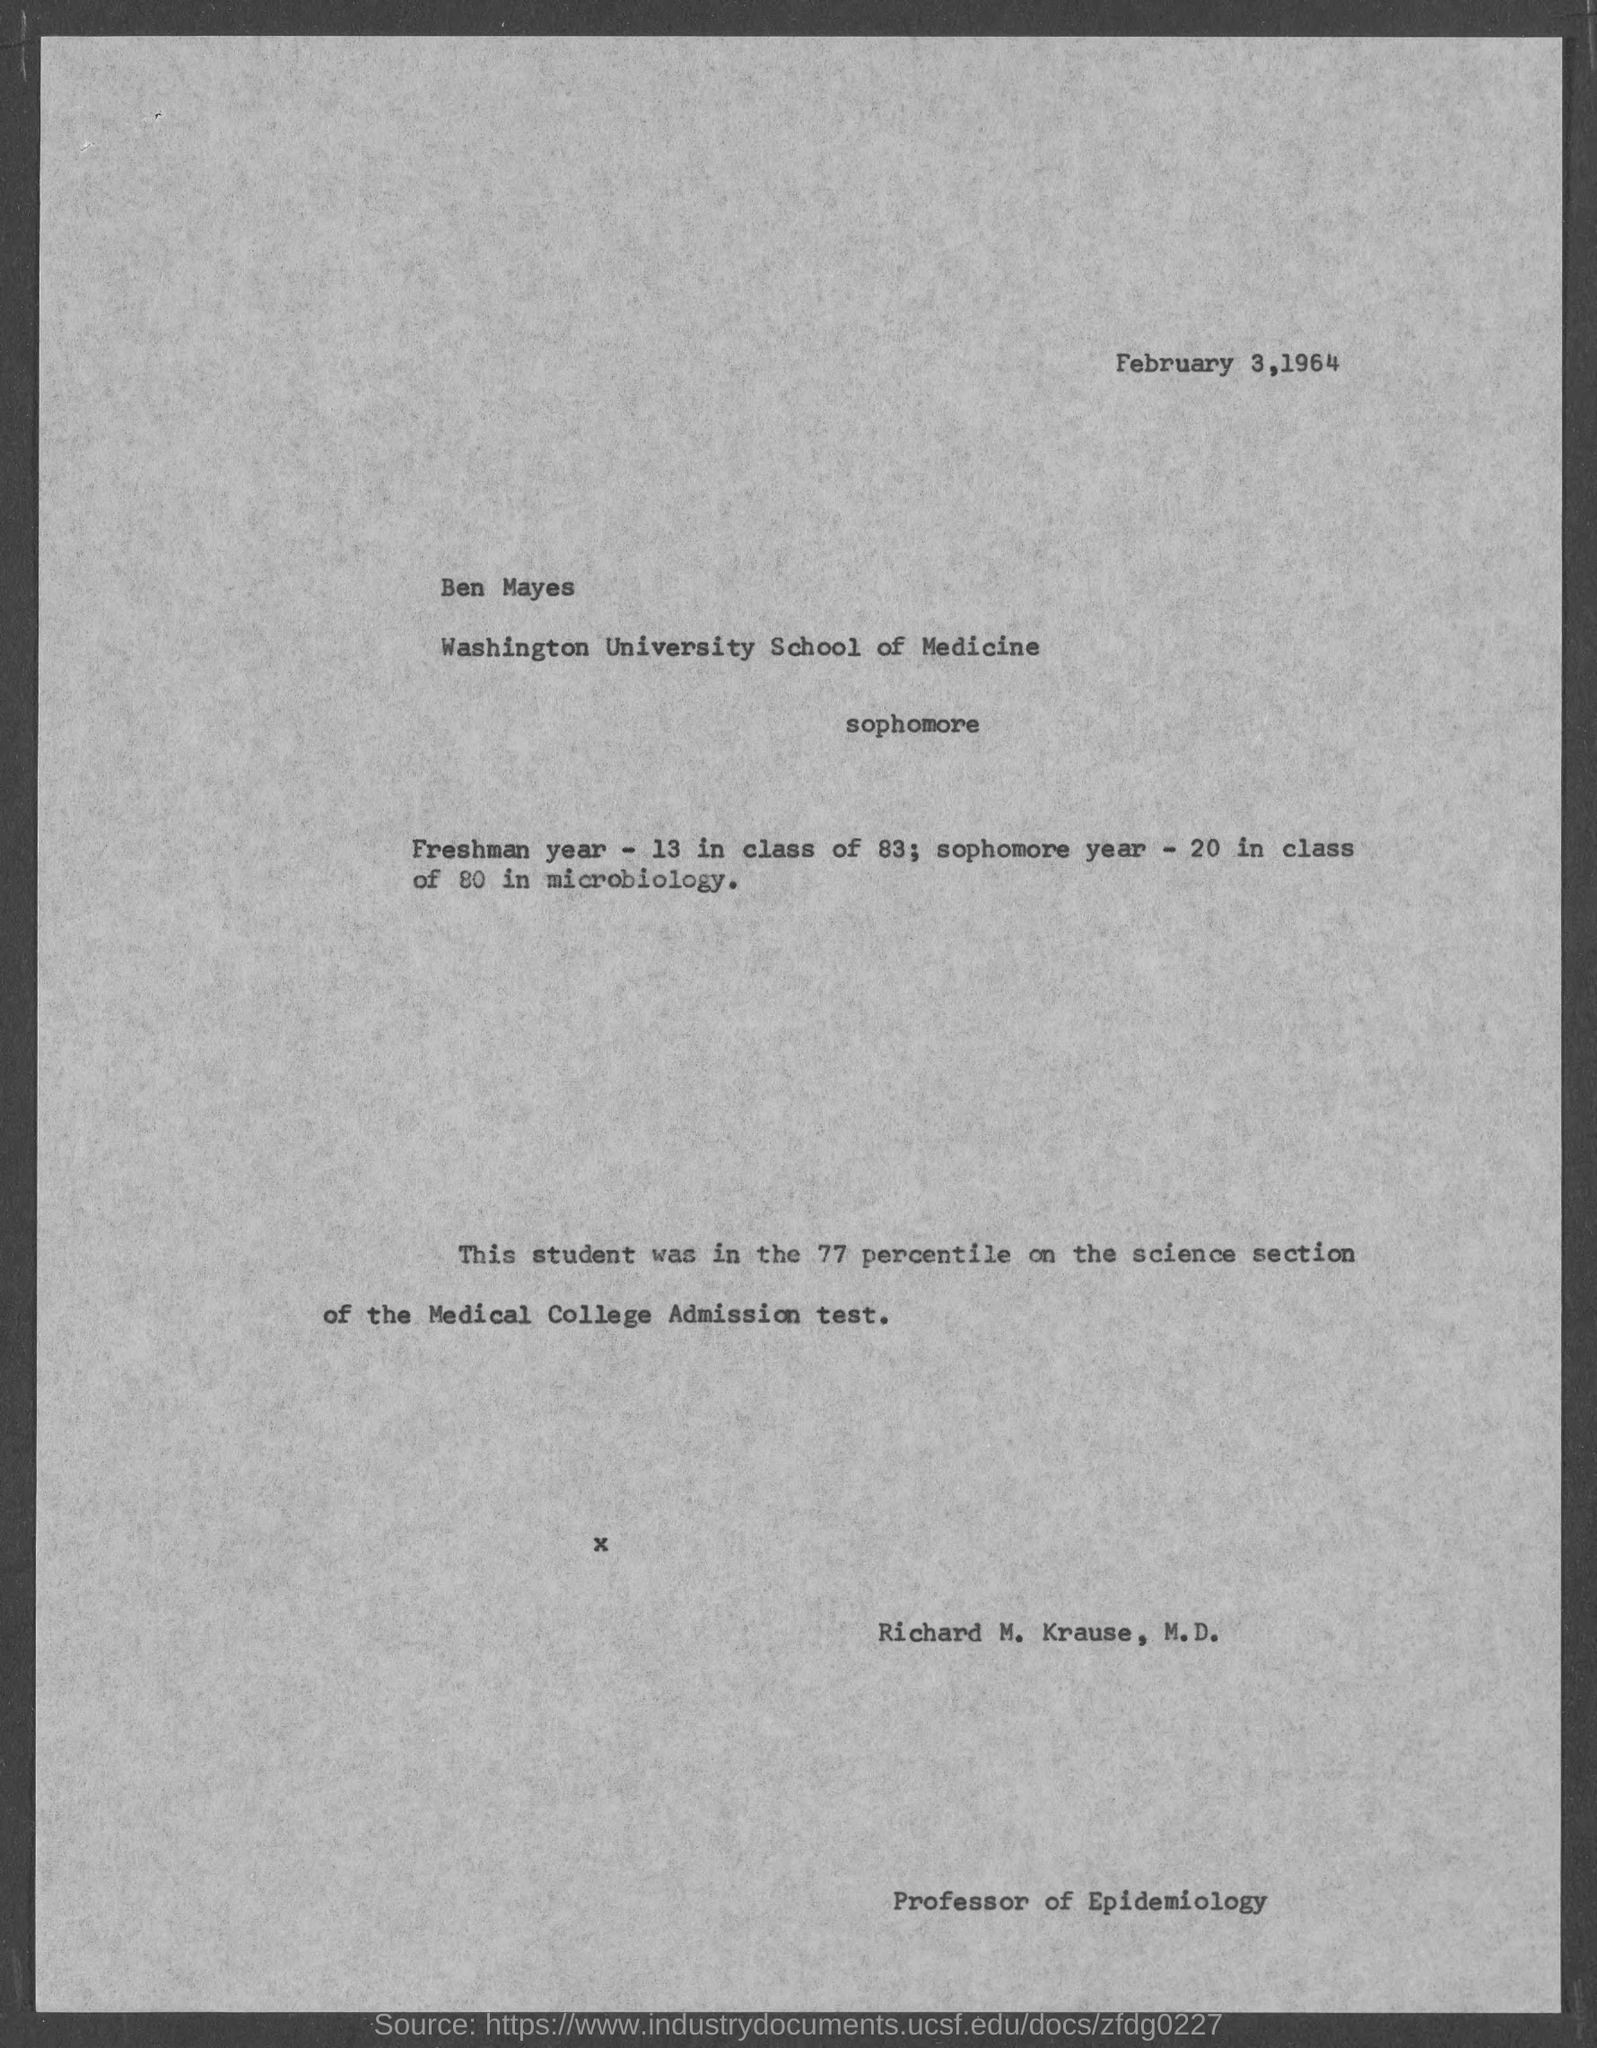What is the date at top of the page?
Provide a short and direct response. February 3, 1964. What is the position of richard m. krause, m.d.?
Your response must be concise. Professor of Epidemiology. 